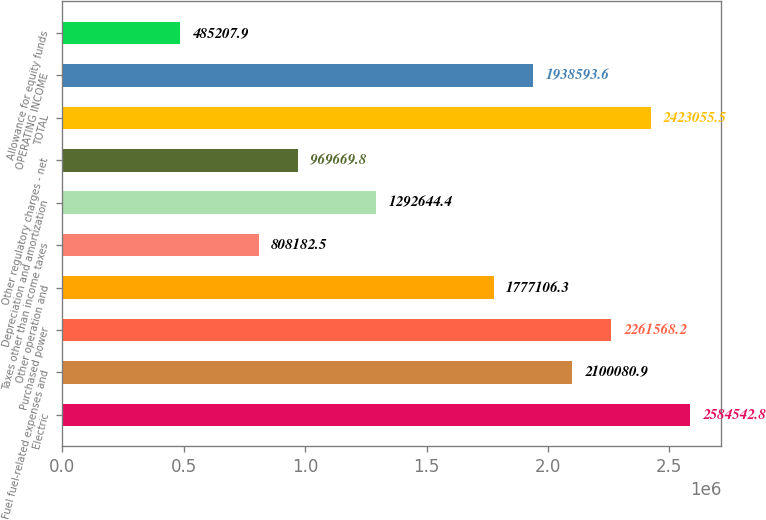<chart> <loc_0><loc_0><loc_500><loc_500><bar_chart><fcel>Electric<fcel>Fuel fuel-related expenses and<fcel>Purchased power<fcel>Other operation and<fcel>Taxes other than income taxes<fcel>Depreciation and amortization<fcel>Other regulatory charges - net<fcel>TOTAL<fcel>OPERATING INCOME<fcel>Allowance for equity funds<nl><fcel>2.58454e+06<fcel>2.10008e+06<fcel>2.26157e+06<fcel>1.77711e+06<fcel>808182<fcel>1.29264e+06<fcel>969670<fcel>2.42306e+06<fcel>1.93859e+06<fcel>485208<nl></chart> 